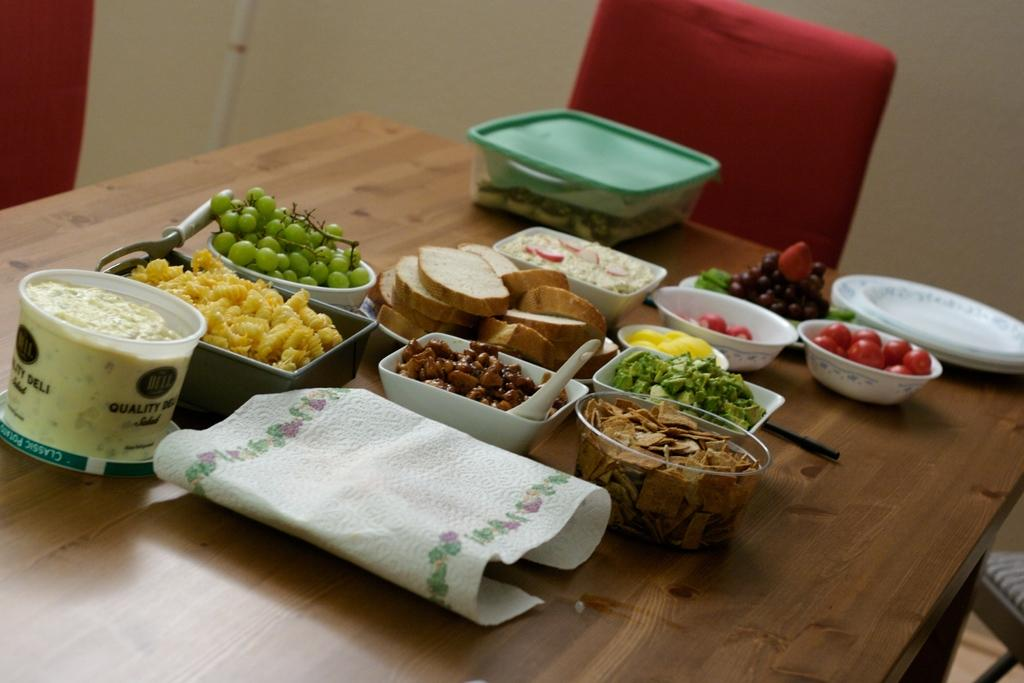What type of food can be seen in the image? There are fruits and other food items in the image. How are the food items presented? The food items are placed in balls. Where are the food items located? They are on a table. What else can be seen in the image? There are chairs visible in the image. What level of fiction is depicted in the image? The image does not depict any fiction; it shows food items placed in balls on a table. 